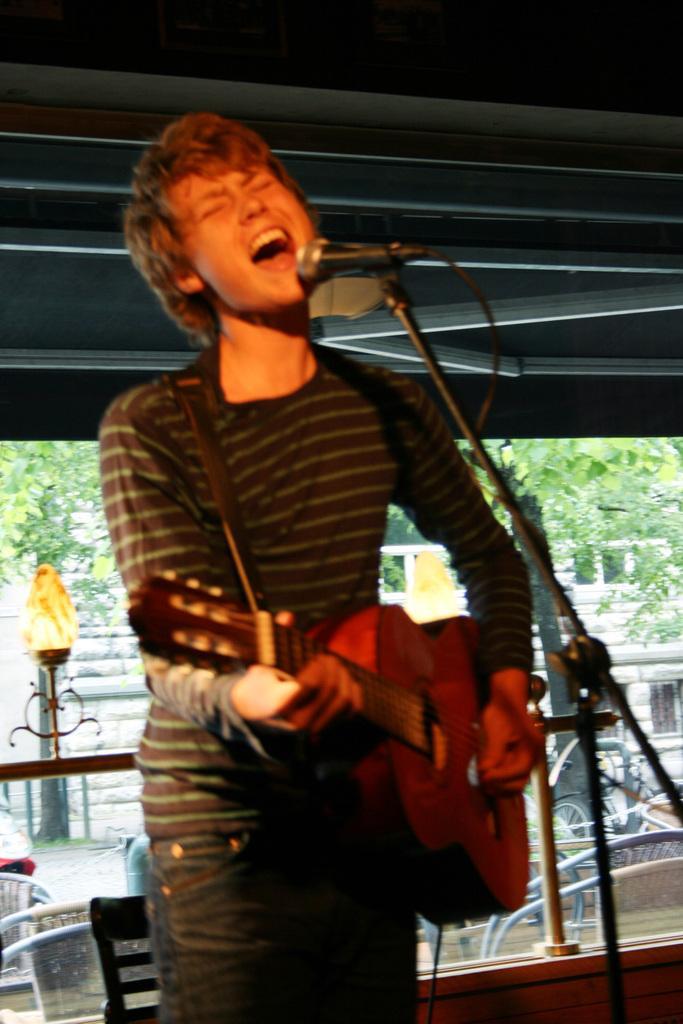How would you summarize this image in a sentence or two? In the image we can see there is a man who is standing and holding guitar in his hand. 